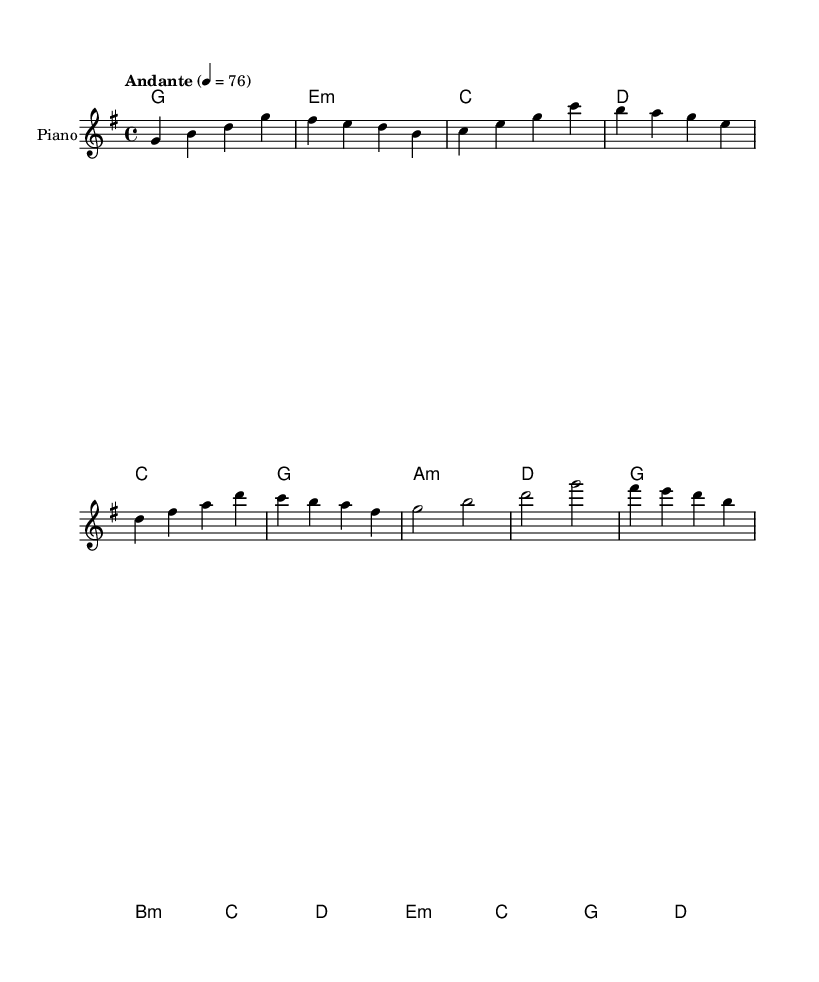What is the key signature of this music? The key signature is G major, indicated by one sharp (F#). This can be identified from the first line of the sheet music where it specifies the key.
Answer: G major What is the time signature of this music? The time signature is 4/4, which is evident from the notation at the beginning of the staff indicating four beats in a measure.
Answer: 4/4 What is the tempo marking? The tempo marking is "Andante," which suggests a moderate walking pace. This is specified at the beginning under the tempo indication.
Answer: Andante How many measures are in the melody section? The melody section contains eight measures, which can be counted by grouping the notes and bars in the melody line.
Answer: 8 What is the last chord in the harmony section called? The last chord is called G major, which can be identified as the harmony section concludes with a G chord.
Answer: G Which chord is repeated in the harmony? The chord G major is repeated in the harmony section. This can be seen as it appears multiple times throughout the progression.
Answer: G major What is the first note of the melody? The first note of the melody is G, which is shown as the opening note in the first measure of the sheet music.
Answer: G 